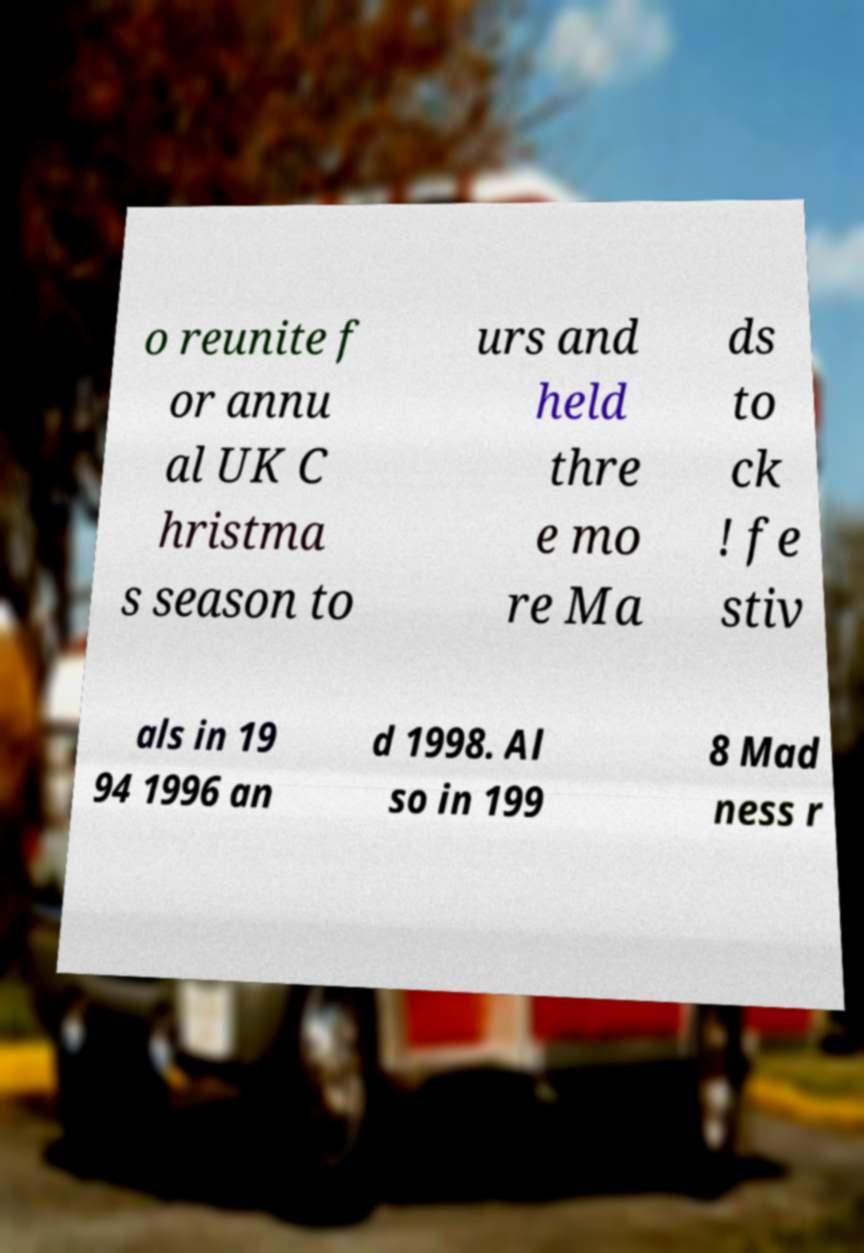Please read and relay the text visible in this image. What does it say? o reunite f or annu al UK C hristma s season to urs and held thre e mo re Ma ds to ck ! fe stiv als in 19 94 1996 an d 1998. Al so in 199 8 Mad ness r 